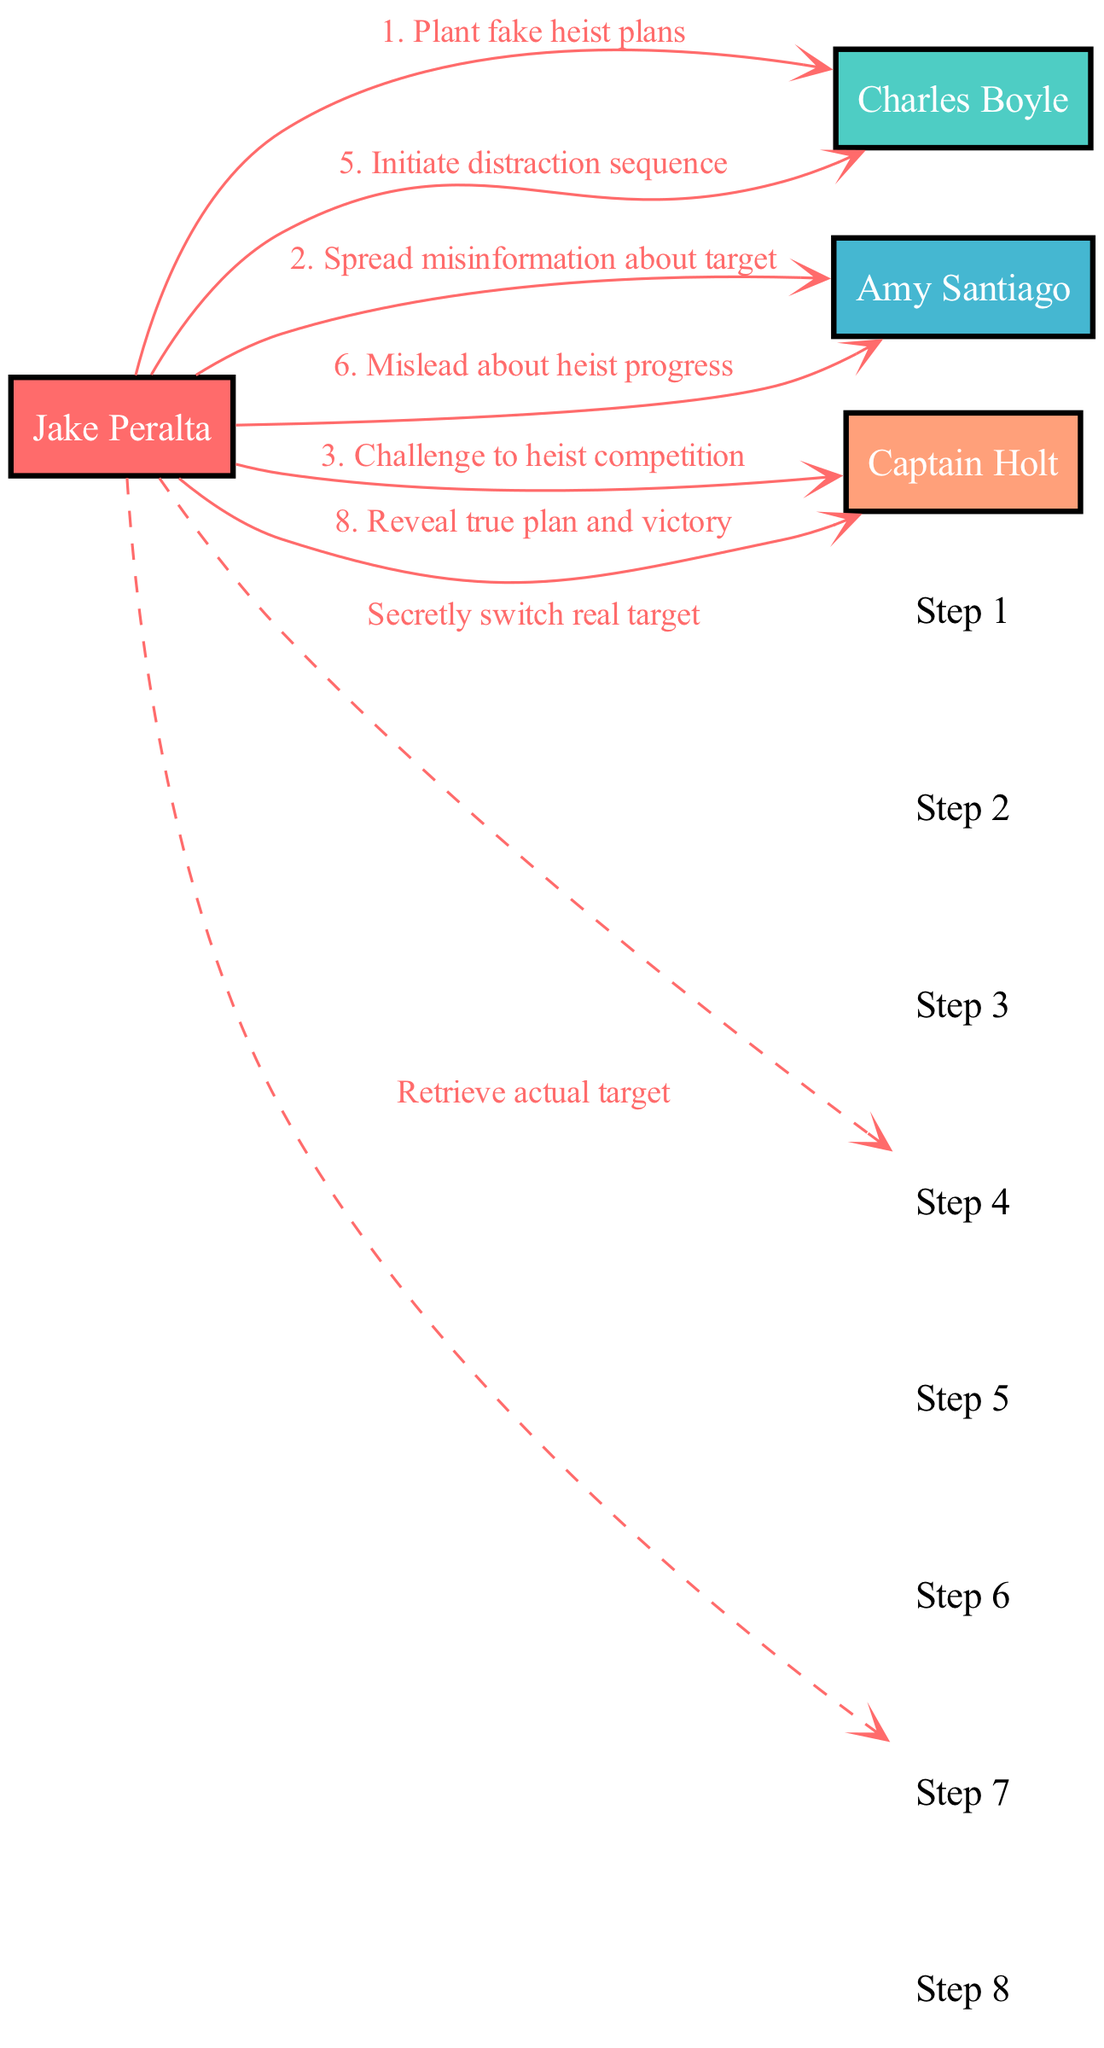What is the first message exchanged in the sequence? The first message in the sequence, from Jake Peralta to Charles Boyle, is "Plant fake heist plans". This is the first step of the sequence diagram.
Answer: Plant fake heist plans How many actors are involved in the heist plan? In the diagram, there are four actors involved: Jake Peralta, Charles Boyle, Amy Santiago, and Captain Holt. Therefore, counting all unique actors gives us the number.
Answer: 4 Who receives misinformation about the target? The message stating "Spread misinformation about target" is directed from Jake Peralta to Amy Santiago, indicating that she is the one who receives the misinformation about the target.
Answer: Amy Santiago What is the last action Jake Peralta takes in the sequence? The last action taken by Jake Peralta according to the sequence is to reveal the true plan and victory to Captain Holt. This shows the culmination of his elaborate scheme.
Answer: Reveal true plan and victory How many steps are there in the heist sequence? Counting each message in the sequence leads to a total of eight distinct steps from start to finish, representing the flow of the heist plan.
Answer: 8 Which actor is involved in all steps of the sequence? By reviewing the diagram, it is evident that Jake Peralta is the actor involved in every single step of the heist plan, indicating his central role in orchestrating the sequence.
Answer: Jake Peralta What type of line connects Jake Peralta to himself? The connection from Jake Peralta to himself in the sequence shows a dashed line, which typically signifies a self-communication in the context of the heist plan.
Answer: Dashed line What does Captain Holt receive from Jake Peralta? In the course of the heist plan, Jake Peralta sends Captain Holt a challenge to a heist competition, and later reveals the true plan. Therefore, he receives interactions including challenges and the final revelation.
Answer: Challenge to heist competition 